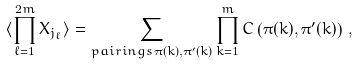Convert formula to latex. <formula><loc_0><loc_0><loc_500><loc_500>\langle \prod ^ { 2 m } _ { \ell = 1 } X _ { j _ { \ell } } \rangle = \sum _ { { p a i r i n g s } \, \pi ( k ) , \pi ^ { \prime } ( k ) } \prod ^ { m } _ { k = 1 } C \left ( \pi ( k ) , \pi ^ { \prime } ( k ) \right ) \, ,</formula> 